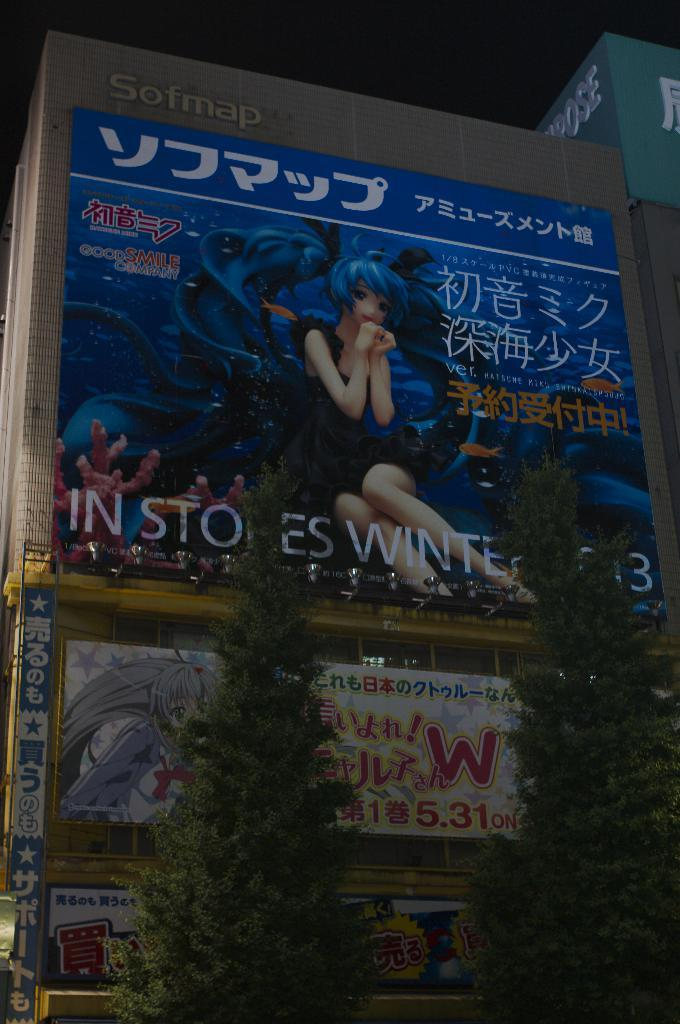<image>
Present a compact description of the photo's key features. the side of a building that says 'sofmap' at the top left 